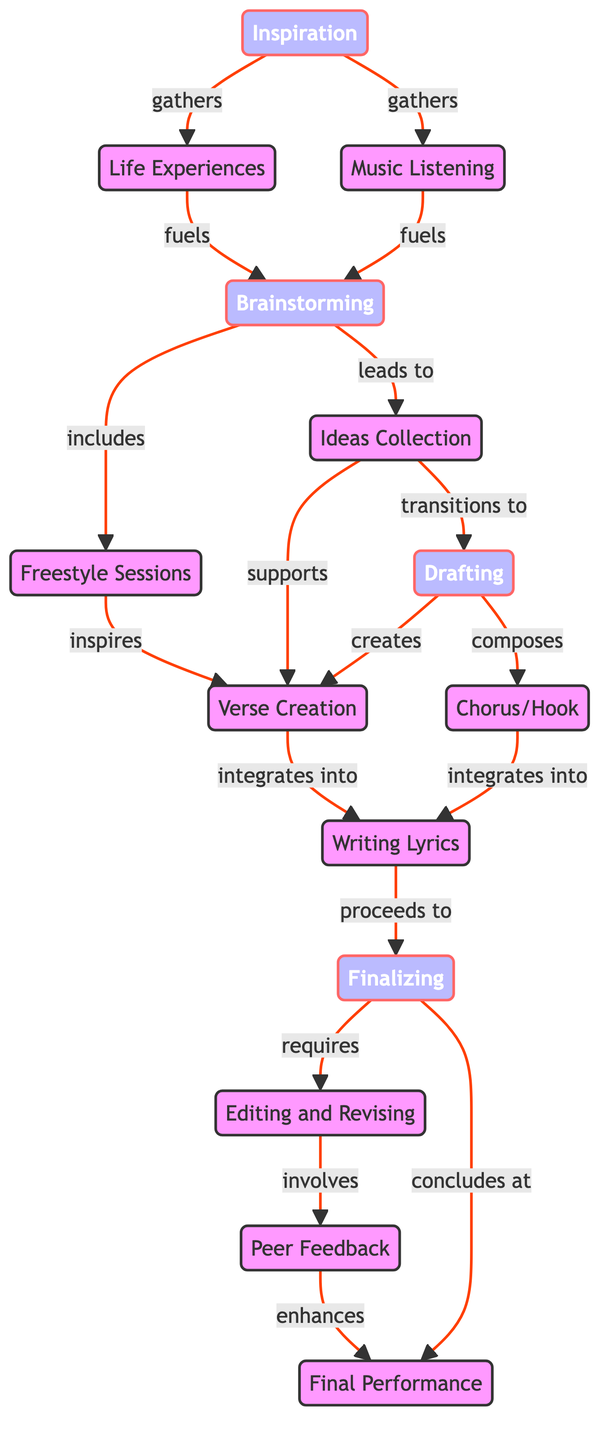What is the first step in the creative process? The diagram indicates that the first step is "Inspiration," which is represented as the starting node.
Answer: Inspiration How many nodes are there in the diagram? By counting the unique nodes listed in the data, we find a total of 14 nodes present in the diagram.
Answer: 14 What are the two types of activities that fuel brainstorming? The diagram shows "Life Experiences" and "Music Listening" as two nodes that lead to "Brainstorming," indicating they both provide inspiration for this phase.
Answer: Life Experiences, Music Listening What does "ideas_collection" transition to? The directed edge clearly points from "Ideas Collection" to "Drafting," showing that this is the next step in the process.
Answer: Drafting Which phase directly requires editing and revising? The arrow from "Finalizing" to "Editing and Revising" indicates that finalizing is the step that necessitates this phase.
Answer: Finalizing What enhances the final performance according to the diagram? The diagram demonstrates that "Peer Feedback" is the node that improves the "Final Performance," as shown by the connecting edge.
Answer: Peer Feedback How do freestyle sessions relate to verse creation? The arrow in the diagram from "Freestyle Sessions" to "Verse Creation" shows that freestyle sessions inspire the creation of verses.
Answer: Inspires Which phase of writing proceeds to finalizing? The diagram connects "Writing Lyrics" to "Finalizing," indicating that writing lyrics is the step just before finalizing the song.
Answer: Writing Lyrics What is the last step in the creative process? The directed graph shows an arrow leading from "Finalizing" to "Final Performance," indicating that finalizing concludes with the performance.
Answer: Final Performance 